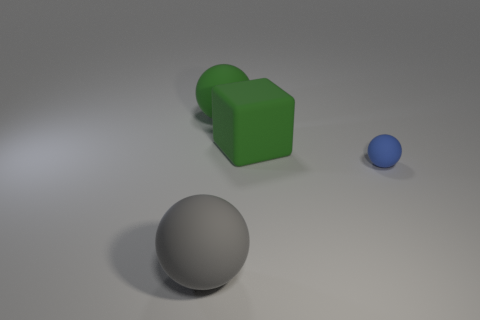Add 4 large green spheres. How many objects exist? 8 Subtract all balls. How many objects are left? 1 Subtract all large things. Subtract all large gray rubber objects. How many objects are left? 0 Add 3 blue balls. How many blue balls are left? 4 Add 2 gray matte balls. How many gray matte balls exist? 3 Subtract 0 brown cubes. How many objects are left? 4 